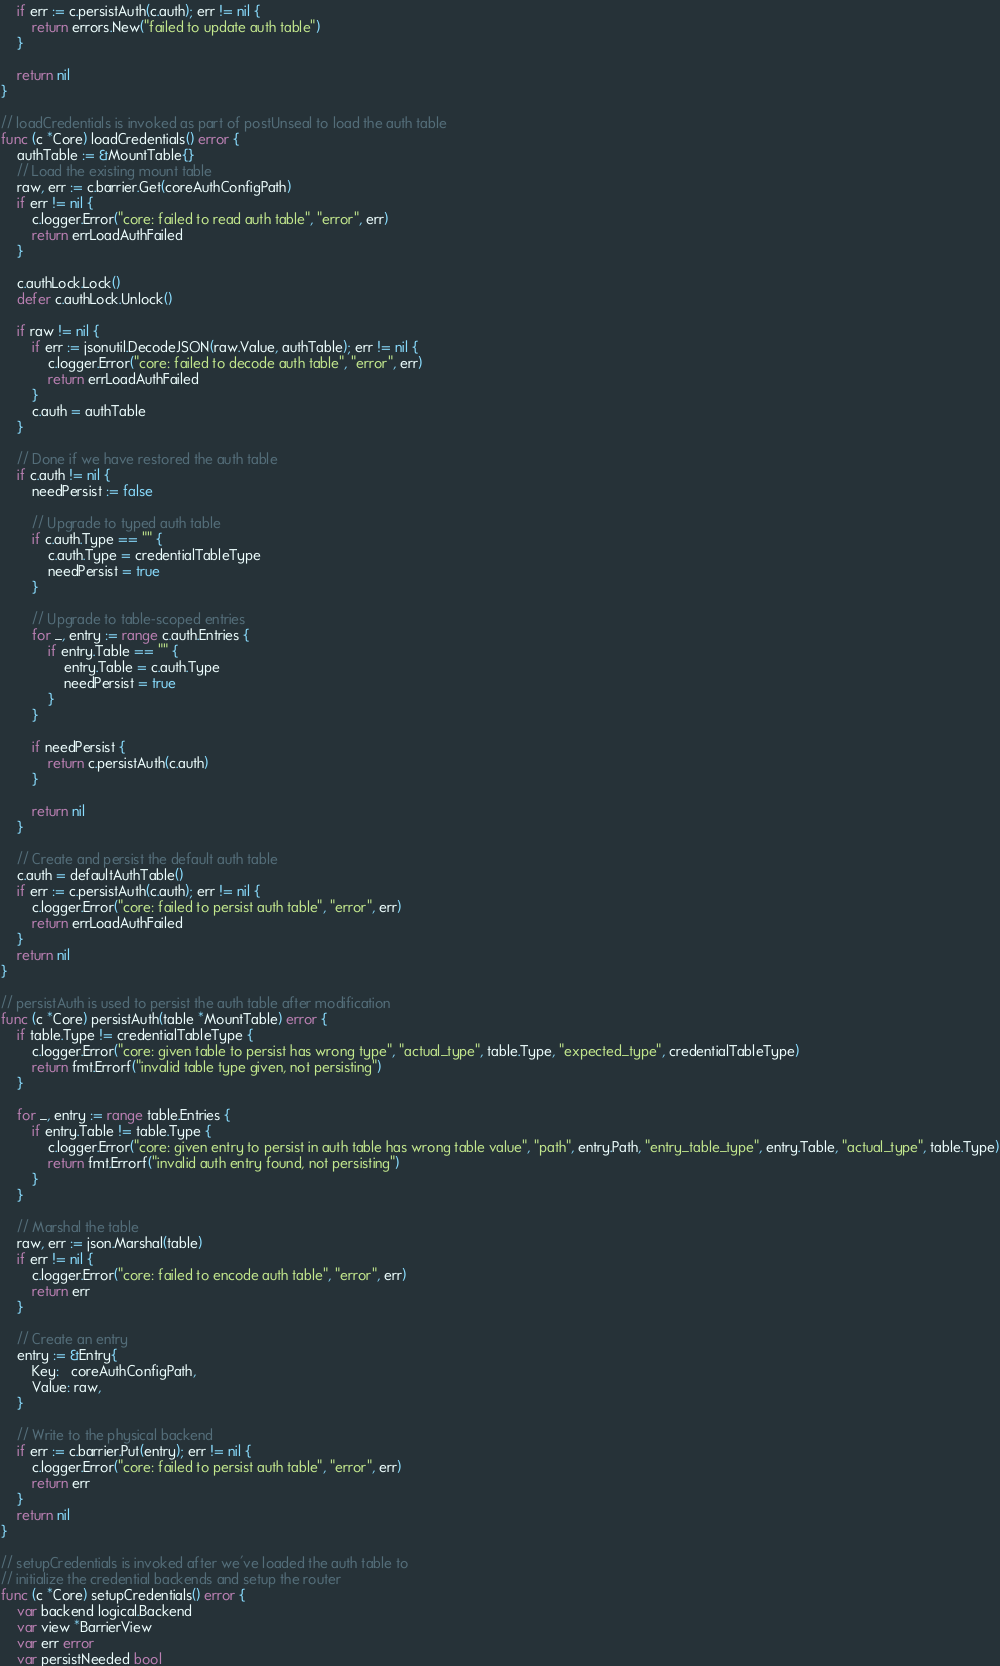<code> <loc_0><loc_0><loc_500><loc_500><_Go_>	if err := c.persistAuth(c.auth); err != nil {
		return errors.New("failed to update auth table")
	}

	return nil
}

// loadCredentials is invoked as part of postUnseal to load the auth table
func (c *Core) loadCredentials() error {
	authTable := &MountTable{}
	// Load the existing mount table
	raw, err := c.barrier.Get(coreAuthConfigPath)
	if err != nil {
		c.logger.Error("core: failed to read auth table", "error", err)
		return errLoadAuthFailed
	}

	c.authLock.Lock()
	defer c.authLock.Unlock()

	if raw != nil {
		if err := jsonutil.DecodeJSON(raw.Value, authTable); err != nil {
			c.logger.Error("core: failed to decode auth table", "error", err)
			return errLoadAuthFailed
		}
		c.auth = authTable
	}

	// Done if we have restored the auth table
	if c.auth != nil {
		needPersist := false

		// Upgrade to typed auth table
		if c.auth.Type == "" {
			c.auth.Type = credentialTableType
			needPersist = true
		}

		// Upgrade to table-scoped entries
		for _, entry := range c.auth.Entries {
			if entry.Table == "" {
				entry.Table = c.auth.Type
				needPersist = true
			}
		}

		if needPersist {
			return c.persistAuth(c.auth)
		}

		return nil
	}

	// Create and persist the default auth table
	c.auth = defaultAuthTable()
	if err := c.persistAuth(c.auth); err != nil {
		c.logger.Error("core: failed to persist auth table", "error", err)
		return errLoadAuthFailed
	}
	return nil
}

// persistAuth is used to persist the auth table after modification
func (c *Core) persistAuth(table *MountTable) error {
	if table.Type != credentialTableType {
		c.logger.Error("core: given table to persist has wrong type", "actual_type", table.Type, "expected_type", credentialTableType)
		return fmt.Errorf("invalid table type given, not persisting")
	}

	for _, entry := range table.Entries {
		if entry.Table != table.Type {
			c.logger.Error("core: given entry to persist in auth table has wrong table value", "path", entry.Path, "entry_table_type", entry.Table, "actual_type", table.Type)
			return fmt.Errorf("invalid auth entry found, not persisting")
		}
	}

	// Marshal the table
	raw, err := json.Marshal(table)
	if err != nil {
		c.logger.Error("core: failed to encode auth table", "error", err)
		return err
	}

	// Create an entry
	entry := &Entry{
		Key:   coreAuthConfigPath,
		Value: raw,
	}

	// Write to the physical backend
	if err := c.barrier.Put(entry); err != nil {
		c.logger.Error("core: failed to persist auth table", "error", err)
		return err
	}
	return nil
}

// setupCredentials is invoked after we've loaded the auth table to
// initialize the credential backends and setup the router
func (c *Core) setupCredentials() error {
	var backend logical.Backend
	var view *BarrierView
	var err error
	var persistNeeded bool
</code> 